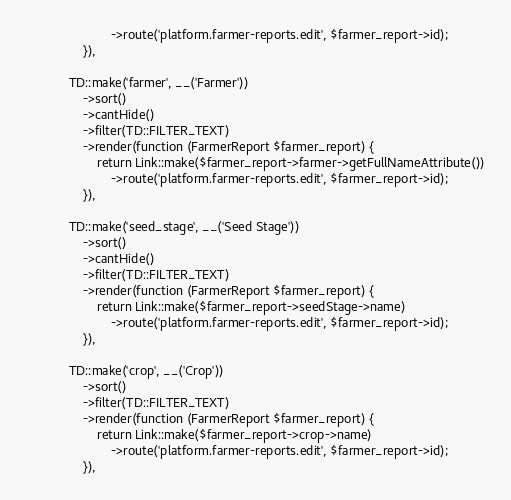Convert code to text. <code><loc_0><loc_0><loc_500><loc_500><_PHP_>                        ->route('platform.farmer-reports.edit', $farmer_report->id);
                }),

            TD::make('farmer', __('Farmer'))
                ->sort()
                ->cantHide()
                ->filter(TD::FILTER_TEXT)
                ->render(function (FarmerReport $farmer_report) {
                    return Link::make($farmer_report->farmer->getFullNameAttribute())
                        ->route('platform.farmer-reports.edit', $farmer_report->id);
                }),

            TD::make('seed_stage', __('Seed Stage'))
                ->sort()
                ->cantHide()
                ->filter(TD::FILTER_TEXT)
                ->render(function (FarmerReport $farmer_report) {
                    return Link::make($farmer_report->seedStage->name)
                        ->route('platform.farmer-reports.edit', $farmer_report->id);
                }),

            TD::make('crop', __('Crop'))
                ->sort()
                ->filter(TD::FILTER_TEXT)
                ->render(function (FarmerReport $farmer_report) {
                    return Link::make($farmer_report->crop->name)
                        ->route('platform.farmer-reports.edit', $farmer_report->id);
                }),
</code> 